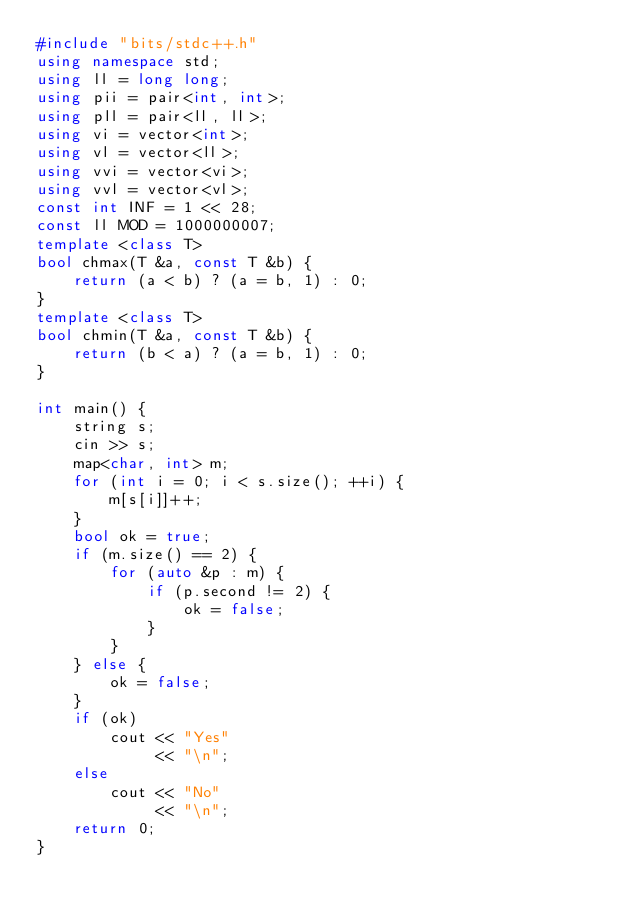<code> <loc_0><loc_0><loc_500><loc_500><_C++_>#include "bits/stdc++.h"
using namespace std;
using ll = long long;
using pii = pair<int, int>;
using pll = pair<ll, ll>;
using vi = vector<int>;
using vl = vector<ll>;
using vvi = vector<vi>;
using vvl = vector<vl>;
const int INF = 1 << 28;
const ll MOD = 1000000007;
template <class T>
bool chmax(T &a, const T &b) {
    return (a < b) ? (a = b, 1) : 0;
}
template <class T>
bool chmin(T &a, const T &b) {
    return (b < a) ? (a = b, 1) : 0;
}

int main() {
    string s;
    cin >> s;
    map<char, int> m;
    for (int i = 0; i < s.size(); ++i) {
        m[s[i]]++;
    }
    bool ok = true;
    if (m.size() == 2) {
        for (auto &p : m) {
            if (p.second != 2) {
                ok = false;
            }
        }
    } else {
        ok = false;
    }
    if (ok)
        cout << "Yes"
             << "\n";
    else
        cout << "No"
             << "\n";
    return 0;
}</code> 